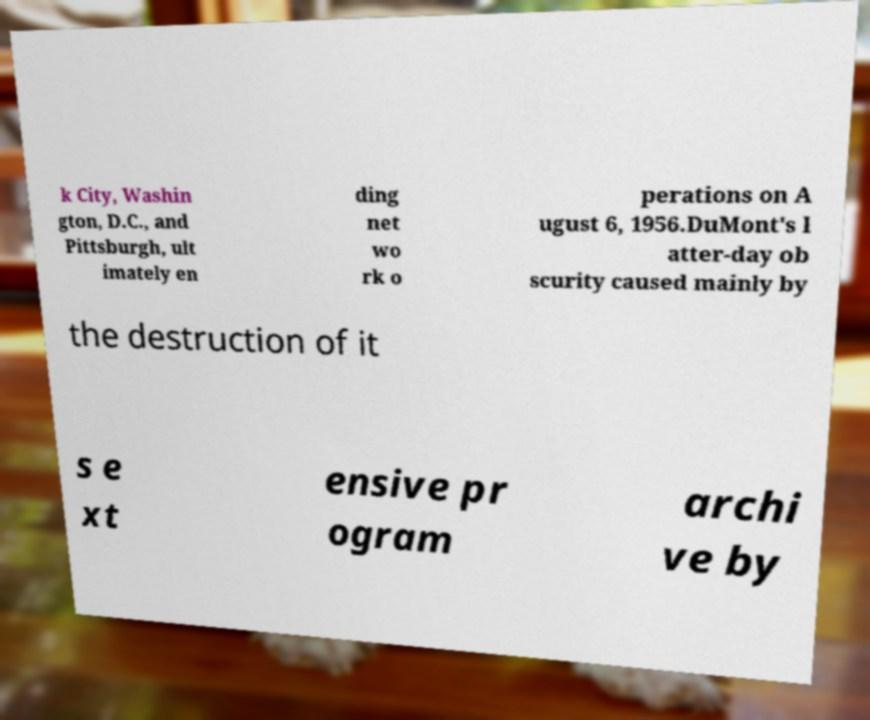Please identify and transcribe the text found in this image. k City, Washin gton, D.C., and Pittsburgh, ult imately en ding net wo rk o perations on A ugust 6, 1956.DuMont's l atter-day ob scurity caused mainly by the destruction of it s e xt ensive pr ogram archi ve by 